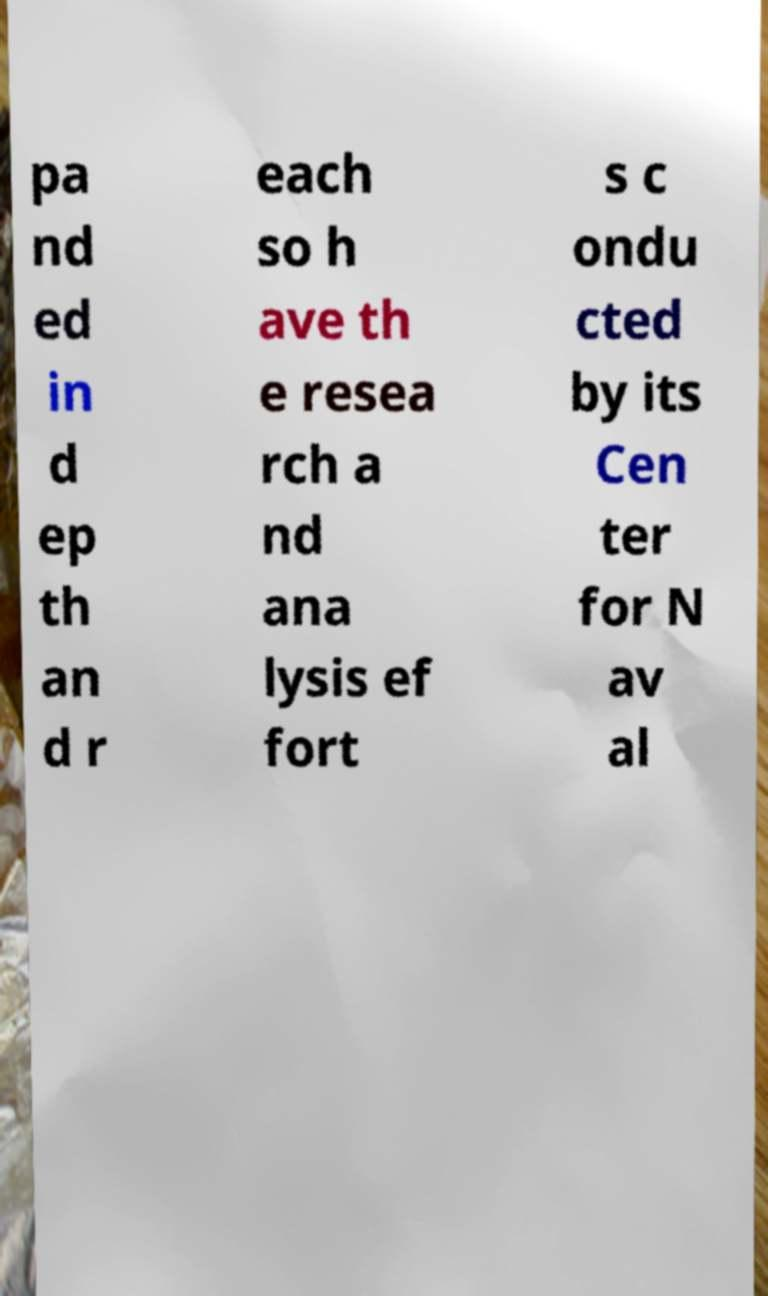For documentation purposes, I need the text within this image transcribed. Could you provide that? pa nd ed in d ep th an d r each so h ave th e resea rch a nd ana lysis ef fort s c ondu cted by its Cen ter for N av al 